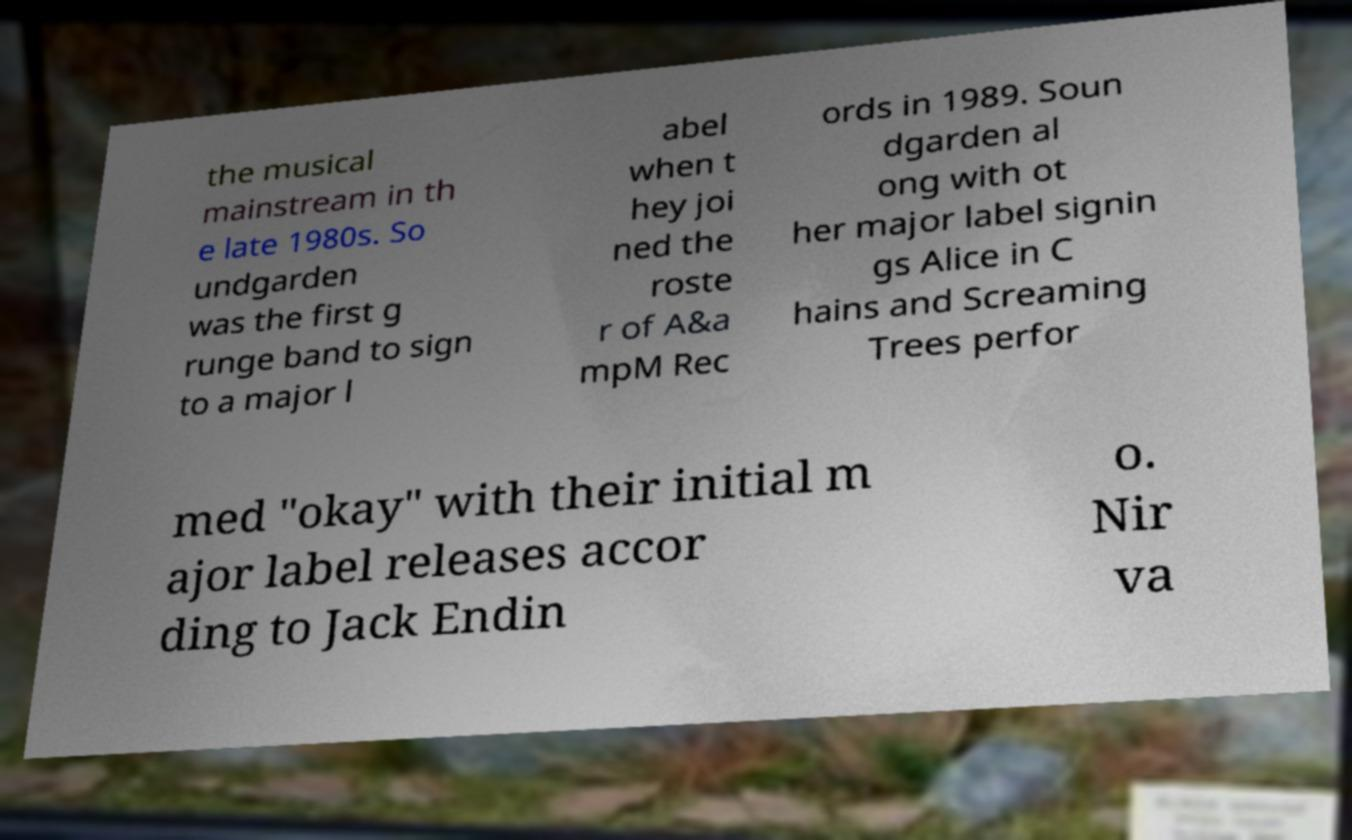I need the written content from this picture converted into text. Can you do that? the musical mainstream in th e late 1980s. So undgarden was the first g runge band to sign to a major l abel when t hey joi ned the roste r of A&a mpM Rec ords in 1989. Soun dgarden al ong with ot her major label signin gs Alice in C hains and Screaming Trees perfor med "okay" with their initial m ajor label releases accor ding to Jack Endin o. Nir va 